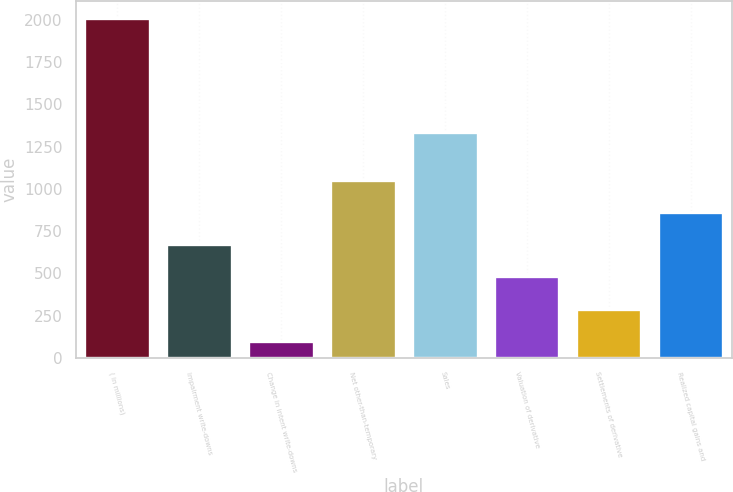Convert chart to OTSL. <chart><loc_0><loc_0><loc_500><loc_500><bar_chart><fcel>( in millions)<fcel>Impairment write-downs<fcel>Change in intent write-downs<fcel>Net other-than-temporary<fcel>Sales<fcel>Valuation of derivative<fcel>Settlements of derivative<fcel>Realized capital gains and<nl><fcel>2011<fcel>673.3<fcel>100<fcel>1055.5<fcel>1336<fcel>482.2<fcel>291.1<fcel>864.4<nl></chart> 